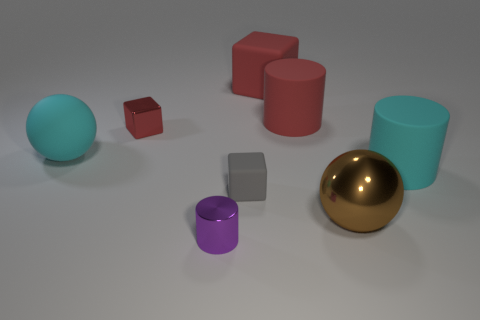Add 2 tiny red objects. How many objects exist? 10 Subtract all balls. How many objects are left? 6 Subtract all large red cylinders. Subtract all red metal things. How many objects are left? 6 Add 7 metallic spheres. How many metallic spheres are left? 8 Add 2 big gray blocks. How many big gray blocks exist? 2 Subtract 0 cyan cubes. How many objects are left? 8 